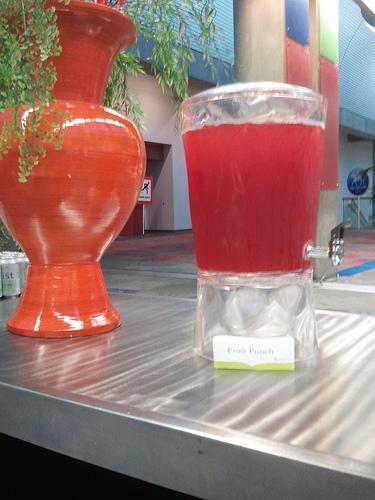How many containers of liquid are visible?
Give a very brief answer. 1. 